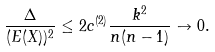Convert formula to latex. <formula><loc_0><loc_0><loc_500><loc_500>\frac { \Delta } { ( E ( X ) ) ^ { 2 } } \leq 2 c ^ { ( 2 ) } \frac { k ^ { 2 } } { n ( n - 1 ) } \to 0 .</formula> 